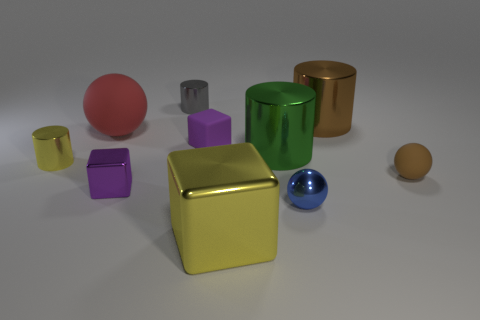Are there any shiny objects of the same color as the large matte ball?
Offer a very short reply. No. Does the big brown object have the same shape as the blue thing?
Provide a succinct answer. No. How many large objects are either yellow matte balls or gray cylinders?
Give a very brief answer. 0. There is a tiny sphere that is made of the same material as the tiny yellow thing; what color is it?
Keep it short and to the point. Blue. What number of gray cylinders have the same material as the brown cylinder?
Provide a short and direct response. 1. There is a shiny thing on the right side of the blue metal thing; does it have the same size as the purple cube behind the small yellow cylinder?
Provide a short and direct response. No. The thing to the right of the cylinder right of the blue metallic object is made of what material?
Your answer should be very brief. Rubber. Are there fewer big yellow shiny things that are left of the green thing than brown matte objects right of the blue sphere?
Ensure brevity in your answer.  No. What is the material of the other small cube that is the same color as the small metal block?
Your answer should be compact. Rubber. Is there any other thing that has the same shape as the large yellow metallic thing?
Your answer should be very brief. Yes. 